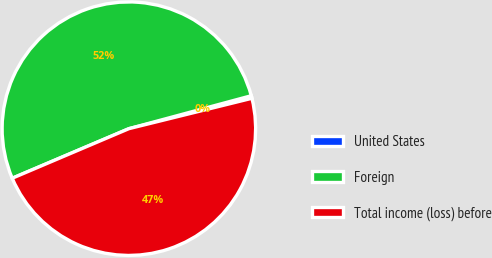<chart> <loc_0><loc_0><loc_500><loc_500><pie_chart><fcel>United States<fcel>Foreign<fcel>Total income (loss) before<nl><fcel>0.33%<fcel>52.21%<fcel>47.46%<nl></chart> 